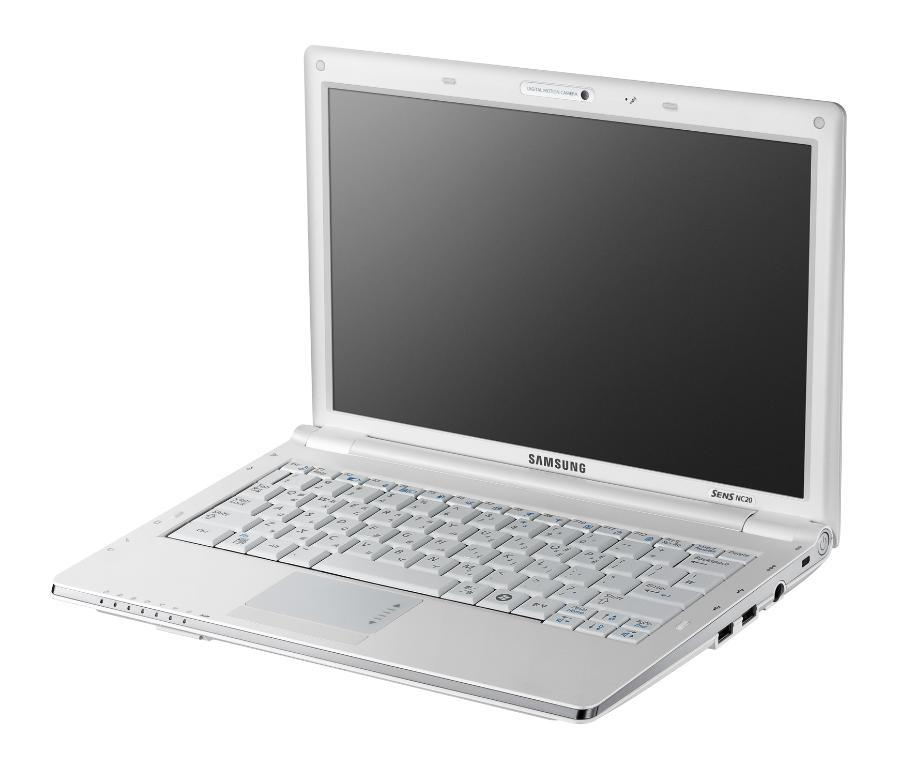<image>
Offer a succinct explanation of the picture presented. Laptop is open and the word is Samsung in Black 